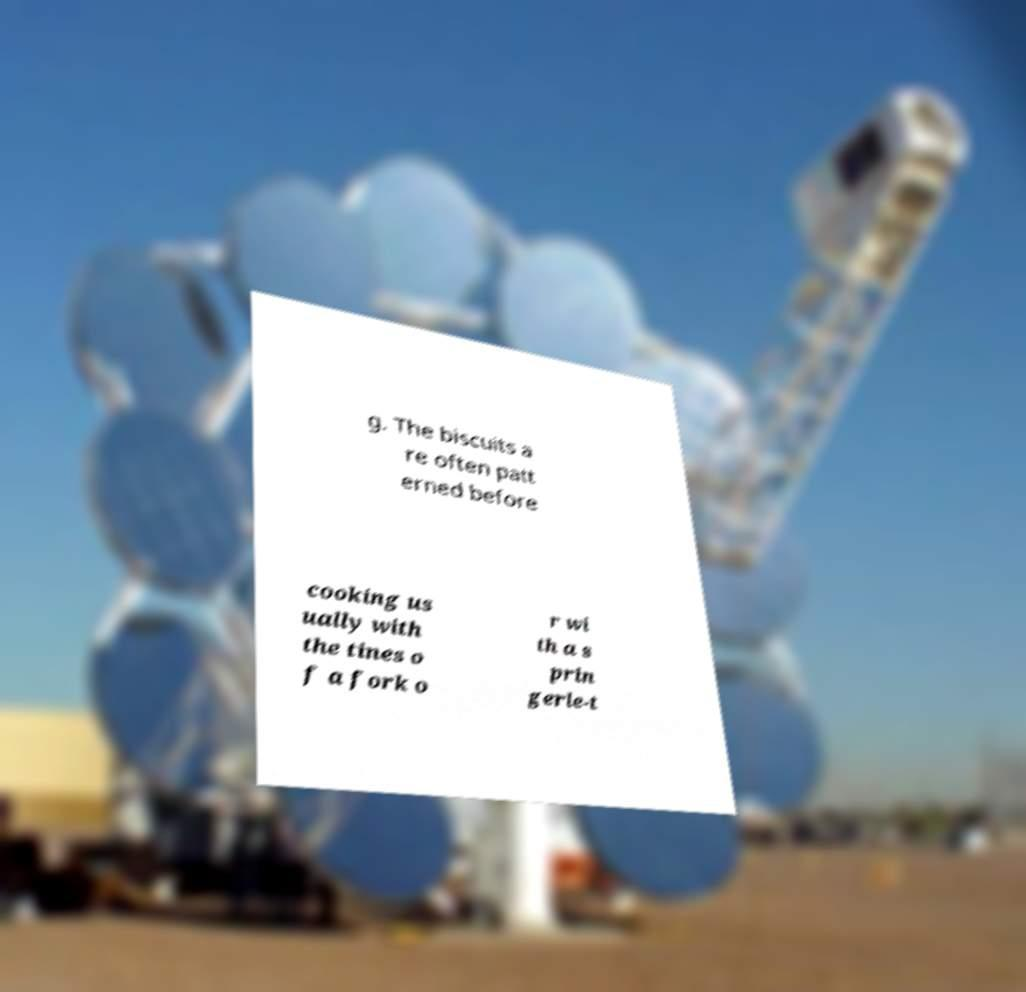I need the written content from this picture converted into text. Can you do that? g. The biscuits a re often patt erned before cooking us ually with the tines o f a fork o r wi th a s prin gerle-t 